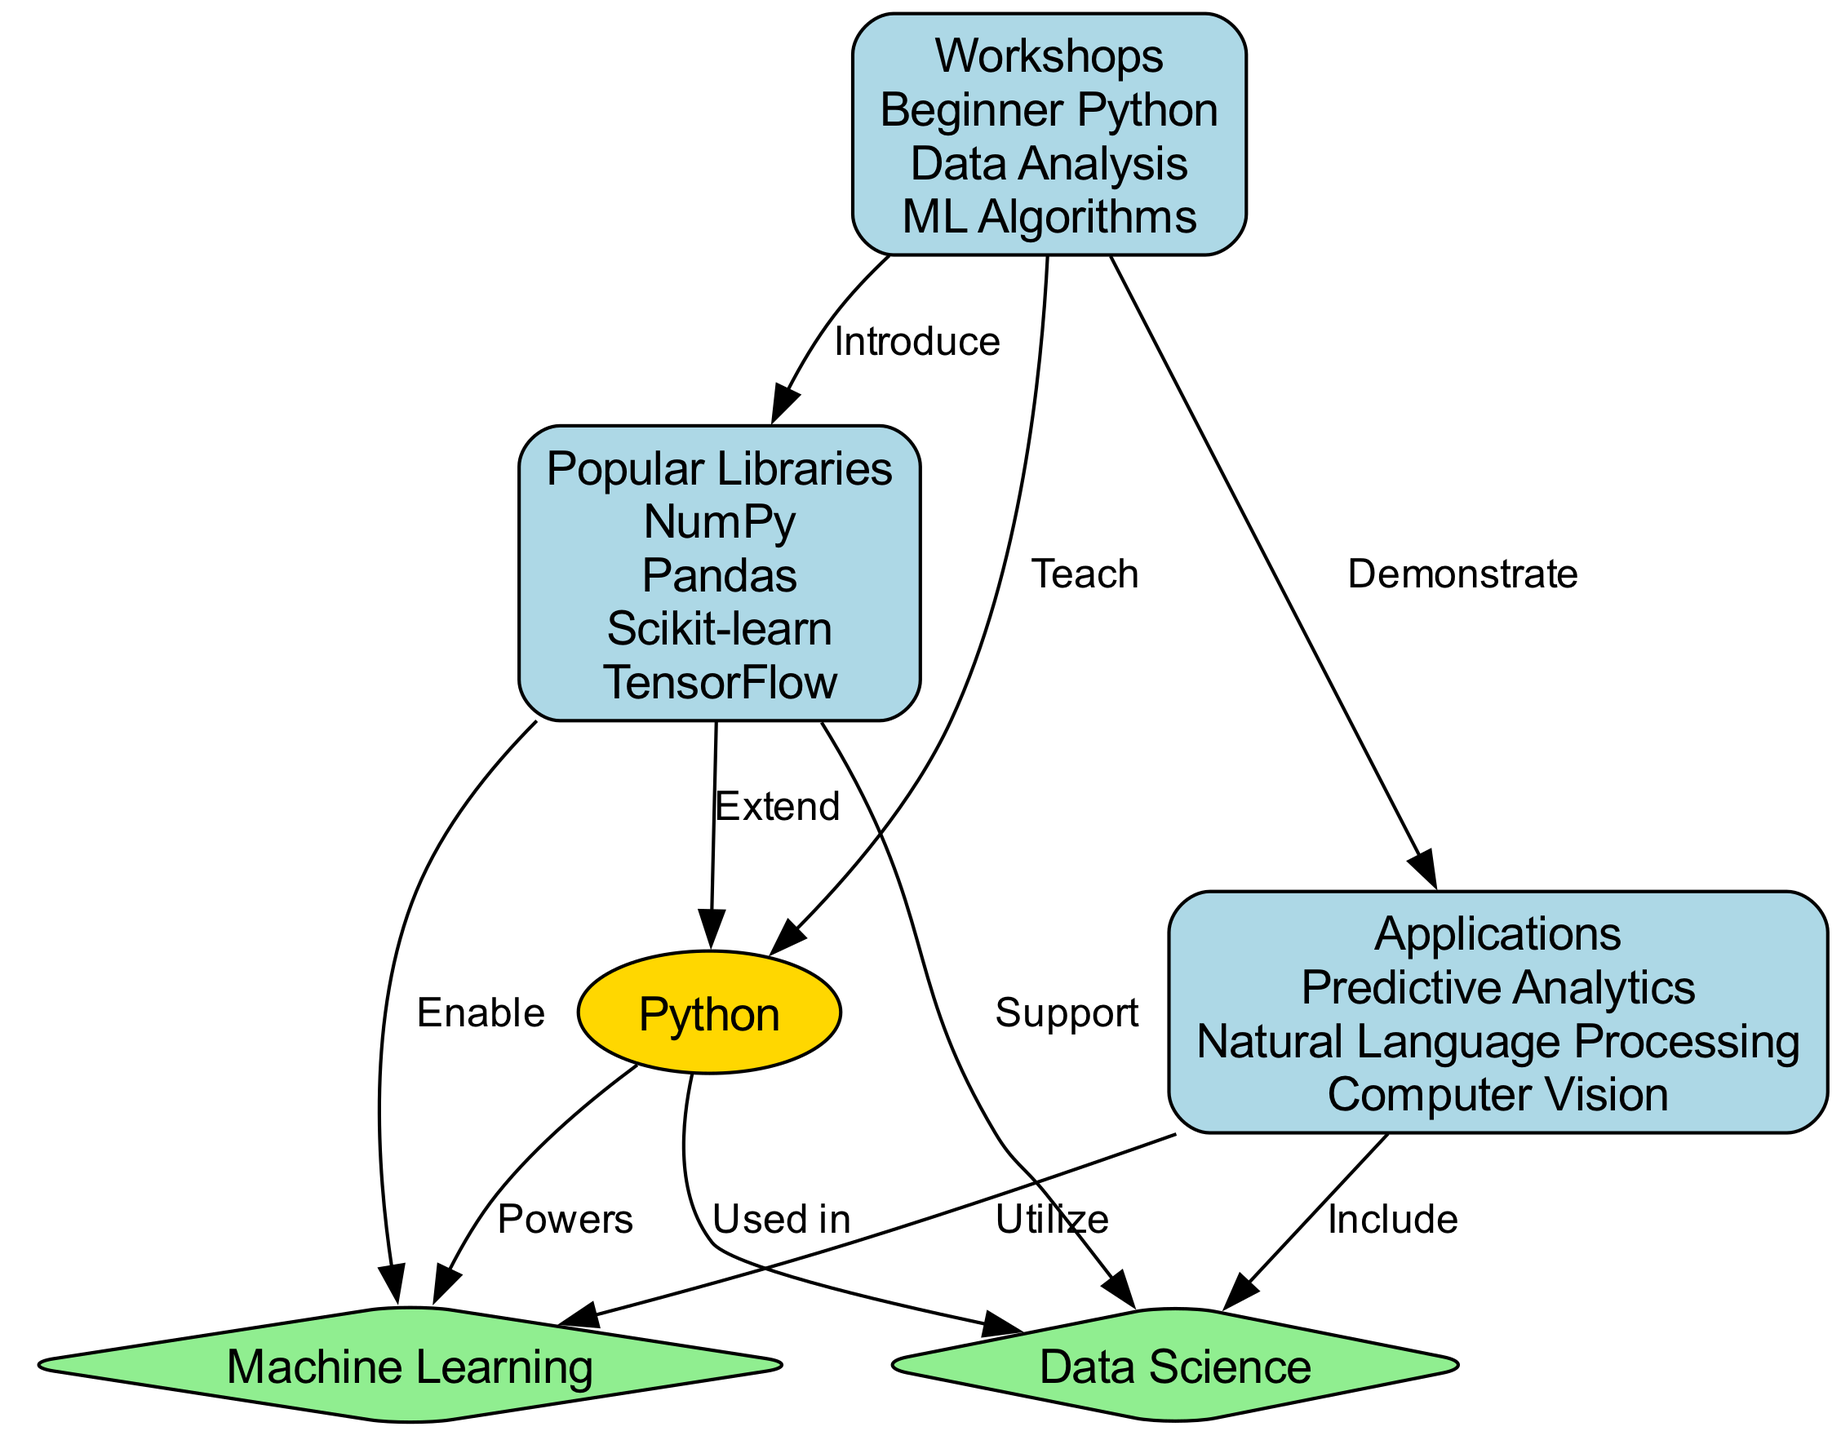What's the main subject of the concept map? The main subject of the concept map is indicated by the central node, which is labeled "Python". This node represents the concept around which the other nodes are organized.
Answer: Python How many nodes are present in the diagram? The diagram includes six distinct nodes: Python, Data Science, Machine Learning, Popular Libraries, Applications, and Workshops. Counting these nodes provides the total number.
Answer: 6 What connection exists between Python and Data Science? The edge connecting Python to Data Science is labeled "Used in", indicating that Python is utilized in Data Science practices. This relationship highlights Python’s role.
Answer: Used in Which libraries are mentioned in the diagram? The concept map lists four libraries that support data science and machine learning: NumPy, Pandas, Scikit-learn, and TensorFlow. These are properties associated with the node "Popular Libraries".
Answer: NumPy, Pandas, Scikit-learn, TensorFlow What kind of applications does Data Science include? According to the diagram, the node "Applications" connects to Data Science with the label "Include", specifying that Predictive Analytics, Natural Language Processing, and Computer Vision are included, as stated in the node properties.
Answer: Predictive Analytics, Natural Language Processing, Computer Vision What is the role of workshops in relation to Python? The node labeled "Workshops" is connected to "Python" indicating that workshops serve to teach Python. This is shown by the edge labeled "Teach" that highlights the educational aspect of workshops concerning Python programming.
Answer: Teach Which library specifically enables Machine Learning according to the diagram? The diagram illustrates that the node "Popular Libraries" has a connection to "Machine Learning" labeled "Enable", denoting that the libraries provide the necessary support for ML tasks with a specific focus.
Answer: Enable How do workshops relate to applications? The edge between "Workshops" and "Applications" is labeled "Demonstrate", showing that workshops aim to showcase or provide practical examples of using applications effectively in the fields of data science or machine learning.
Answer: Demonstrate 